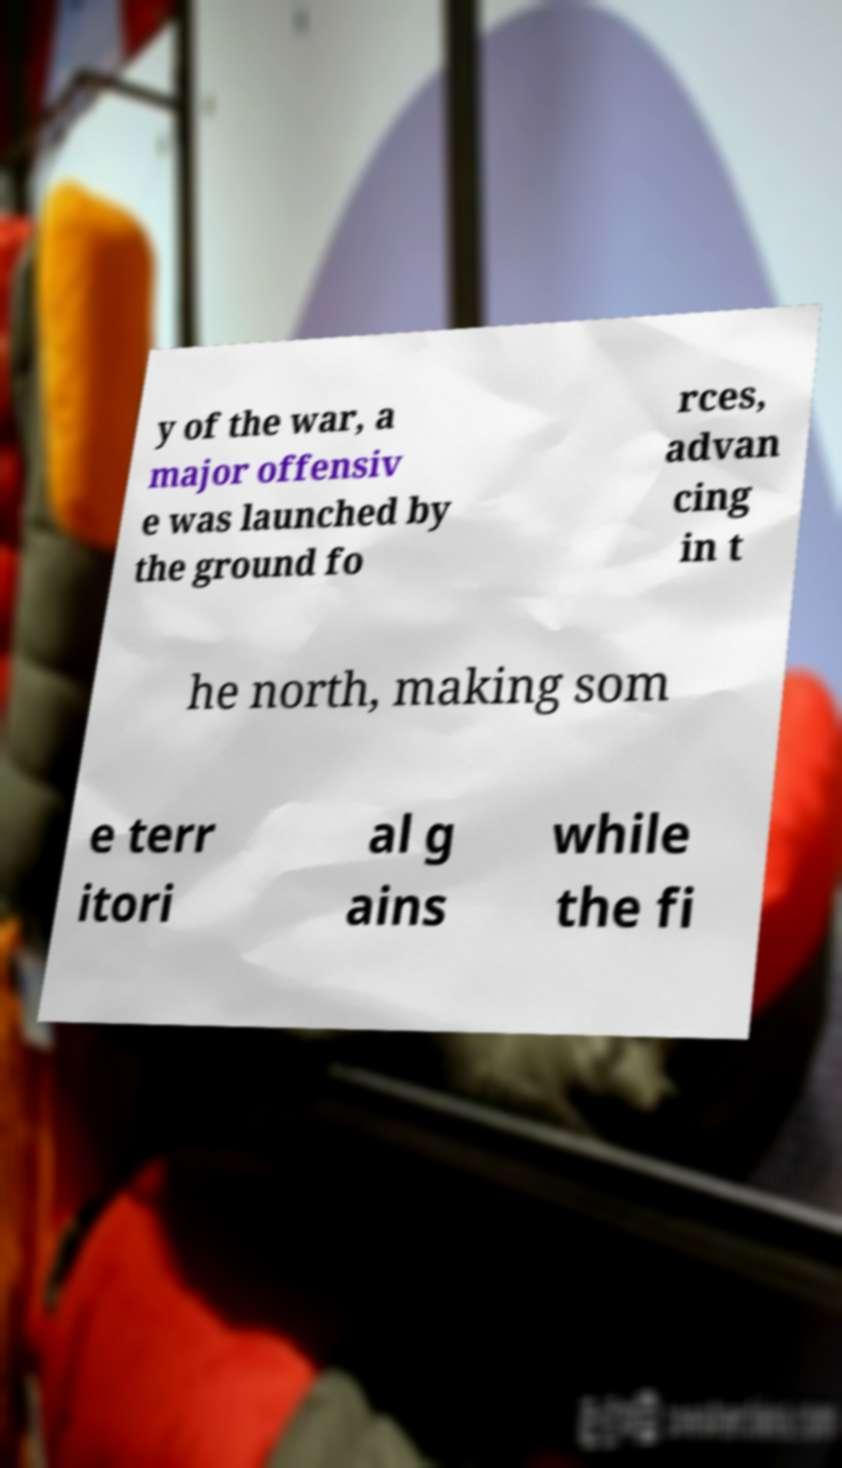Can you read and provide the text displayed in the image?This photo seems to have some interesting text. Can you extract and type it out for me? y of the war, a major offensiv e was launched by the ground fo rces, advan cing in t he north, making som e terr itori al g ains while the fi 